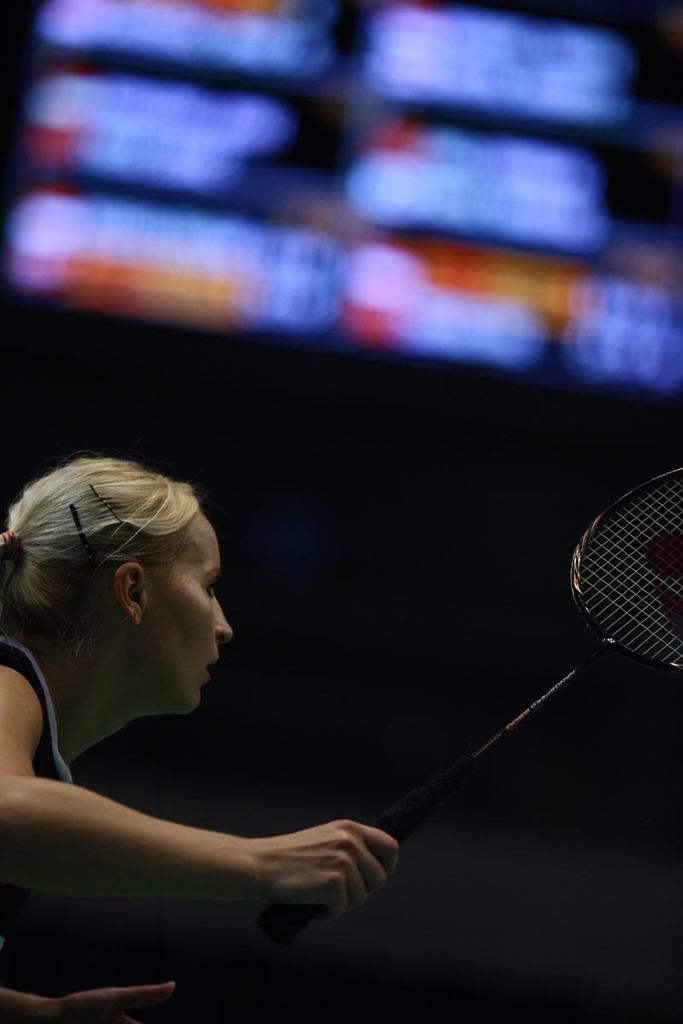What is the main subject of the image? The main subject of the image is a woman. What is the woman holding in her hand? The woman is holding a racket in her hand. What type of cave is visible in the background of the image? There is no cave present in the image; it features a woman holding a racket. 